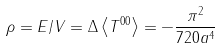Convert formula to latex. <formula><loc_0><loc_0><loc_500><loc_500>\rho = E / V = \Delta \left \langle T ^ { 0 0 } \right \rangle = - \frac { \pi ^ { 2 } } { 7 2 0 a ^ { 4 } }</formula> 